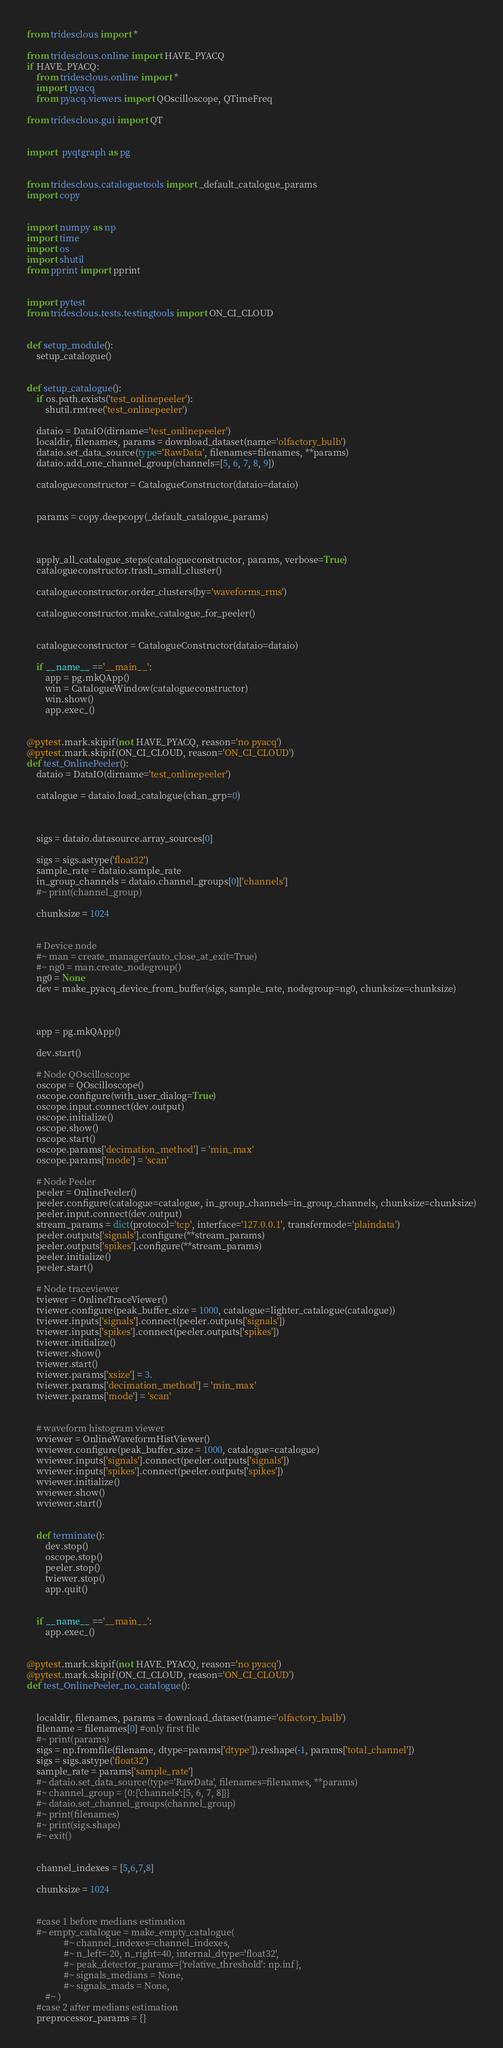Convert code to text. <code><loc_0><loc_0><loc_500><loc_500><_Python_>from tridesclous import *

from tridesclous.online import HAVE_PYACQ
if HAVE_PYACQ:
    from tridesclous.online import *
    import pyacq
    from pyacq.viewers import QOscilloscope, QTimeFreq

from tridesclous.gui import QT


import  pyqtgraph as pg


from tridesclous.cataloguetools import _default_catalogue_params
import copy


import numpy as np
import time
import os
import shutil
from pprint import pprint


import pytest
from tridesclous.tests.testingtools import ON_CI_CLOUD


def setup_module():
    setup_catalogue()


def setup_catalogue():
    if os.path.exists('test_onlinepeeler'):
        shutil.rmtree('test_onlinepeeler')
    
    dataio = DataIO(dirname='test_onlinepeeler')
    localdir, filenames, params = download_dataset(name='olfactory_bulb')
    dataio.set_data_source(type='RawData', filenames=filenames, **params)
    dataio.add_one_channel_group(channels=[5, 6, 7, 8, 9])
    
    catalogueconstructor = CatalogueConstructor(dataio=dataio)
    
    
    params = copy.deepcopy(_default_catalogue_params)
    

    
    apply_all_catalogue_steps(catalogueconstructor, params, verbose=True)
    catalogueconstructor.trash_small_cluster()
    
    catalogueconstructor.order_clusters(by='waveforms_rms')
    
    catalogueconstructor.make_catalogue_for_peeler()


    catalogueconstructor = CatalogueConstructor(dataio=dataio)
    
    if __name__ =='__main__':
        app = pg.mkQApp()
        win = CatalogueWindow(catalogueconstructor)
        win.show()
        app.exec_()

    
@pytest.mark.skipif(not HAVE_PYACQ, reason='no pyacq')
@pytest.mark.skipif(ON_CI_CLOUD, reason='ON_CI_CLOUD')
def test_OnlinePeeler():
    dataio = DataIO(dirname='test_onlinepeeler')

    catalogue = dataio.load_catalogue(chan_grp=0)
    
    
    
    sigs = dataio.datasource.array_sources[0]
    
    sigs = sigs.astype('float32')
    sample_rate = dataio.sample_rate
    in_group_channels = dataio.channel_groups[0]['channels']
    #~ print(channel_group)
    
    chunksize = 1024
    
    
    # Device node
    #~ man = create_manager(auto_close_at_exit=True)
    #~ ng0 = man.create_nodegroup()
    ng0 = None
    dev = make_pyacq_device_from_buffer(sigs, sample_rate, nodegroup=ng0, chunksize=chunksize)
    

    
    app = pg.mkQApp()
    
    dev.start()
    
    # Node QOscilloscope
    oscope = QOscilloscope()
    oscope.configure(with_user_dialog=True)
    oscope.input.connect(dev.output)
    oscope.initialize()
    oscope.show()
    oscope.start()
    oscope.params['decimation_method'] = 'min_max'
    oscope.params['mode'] = 'scan'    

    # Node Peeler
    peeler = OnlinePeeler()
    peeler.configure(catalogue=catalogue, in_group_channels=in_group_channels, chunksize=chunksize)
    peeler.input.connect(dev.output)
    stream_params = dict(protocol='tcp', interface='127.0.0.1', transfermode='plaindata')
    peeler.outputs['signals'].configure(**stream_params)
    peeler.outputs['spikes'].configure(**stream_params)
    peeler.initialize()
    peeler.start()
    
    # Node traceviewer
    tviewer = OnlineTraceViewer()
    tviewer.configure(peak_buffer_size = 1000, catalogue=lighter_catalogue(catalogue))
    tviewer.inputs['signals'].connect(peeler.outputs['signals'])
    tviewer.inputs['spikes'].connect(peeler.outputs['spikes'])
    tviewer.initialize()
    tviewer.show()
    tviewer.start()
    tviewer.params['xsize'] = 3.
    tviewer.params['decimation_method'] = 'min_max'
    tviewer.params['mode'] = 'scan'

    
    # waveform histogram viewer
    wviewer = OnlineWaveformHistViewer()
    wviewer.configure(peak_buffer_size = 1000, catalogue=catalogue)
    wviewer.inputs['signals'].connect(peeler.outputs['signals'])
    wviewer.inputs['spikes'].connect(peeler.outputs['spikes'])
    wviewer.initialize()
    wviewer.show()
    wviewer.start()    
    
    
    def terminate():
        dev.stop()
        oscope.stop()
        peeler.stop()
        tviewer.stop()
        app.quit()
    
    
    if __name__ =='__main__':
        app.exec_()
    

@pytest.mark.skipif(not HAVE_PYACQ, reason='no pyacq')
@pytest.mark.skipif(ON_CI_CLOUD, reason='ON_CI_CLOUD')
def test_OnlinePeeler_no_catalogue():
    

    localdir, filenames, params = download_dataset(name='olfactory_bulb')
    filename = filenames[0] #only first file
    #~ print(params)
    sigs = np.fromfile(filename, dtype=params['dtype']).reshape(-1, params['total_channel'])
    sigs = sigs.astype('float32')
    sample_rate = params['sample_rate']
    #~ dataio.set_data_source(type='RawData', filenames=filenames, **params)
    #~ channel_group = {0:{'channels':[5, 6, 7, 8]}}
    #~ dataio.set_channel_groups(channel_group)
    #~ print(filenames)
    #~ print(sigs.shape)
    #~ exit()
    
    
    channel_indexes = [5,6,7,8]
    
    chunksize = 1024
    
    
    #case 1 before medians estimation
    #~ empty_catalogue = make_empty_catalogue(
                #~ channel_indexes=channel_indexes,
                #~ n_left=-20, n_right=40, internal_dtype='float32',
                #~ peak_detector_params={'relative_threshold': np.inf},
                #~ signals_medians = None,
                #~ signals_mads = None,
        #~ )
    #case 2 after medians estimation
    preprocessor_params = {}</code> 